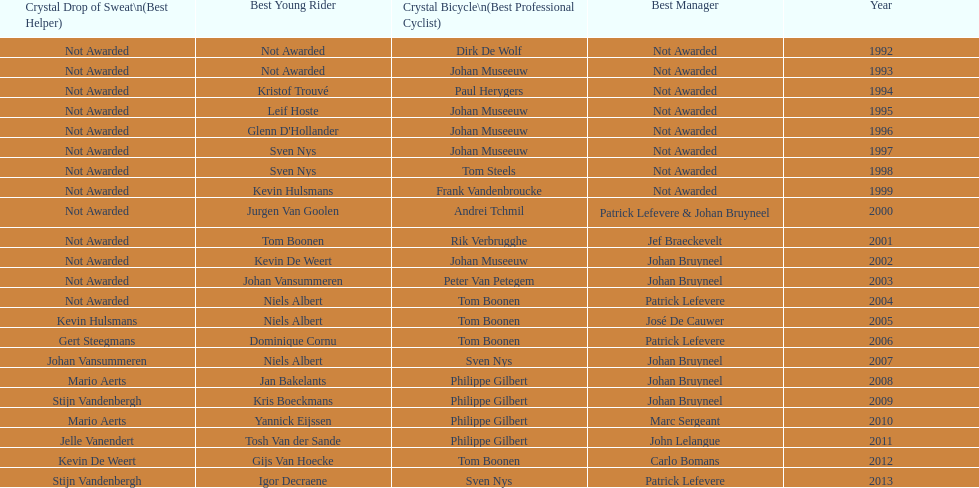Would you mind parsing the complete table? {'header': ['Crystal Drop of Sweat\\n(Best Helper)', 'Best Young Rider', 'Crystal Bicycle\\n(Best Professional Cyclist)', 'Best Manager', 'Year'], 'rows': [['Not Awarded', 'Not Awarded', 'Dirk De Wolf', 'Not Awarded', '1992'], ['Not Awarded', 'Not Awarded', 'Johan Museeuw', 'Not Awarded', '1993'], ['Not Awarded', 'Kristof Trouvé', 'Paul Herygers', 'Not Awarded', '1994'], ['Not Awarded', 'Leif Hoste', 'Johan Museeuw', 'Not Awarded', '1995'], ['Not Awarded', "Glenn D'Hollander", 'Johan Museeuw', 'Not Awarded', '1996'], ['Not Awarded', 'Sven Nys', 'Johan Museeuw', 'Not Awarded', '1997'], ['Not Awarded', 'Sven Nys', 'Tom Steels', 'Not Awarded', '1998'], ['Not Awarded', 'Kevin Hulsmans', 'Frank Vandenbroucke', 'Not Awarded', '1999'], ['Not Awarded', 'Jurgen Van Goolen', 'Andrei Tchmil', 'Patrick Lefevere & Johan Bruyneel', '2000'], ['Not Awarded', 'Tom Boonen', 'Rik Verbrugghe', 'Jef Braeckevelt', '2001'], ['Not Awarded', 'Kevin De Weert', 'Johan Museeuw', 'Johan Bruyneel', '2002'], ['Not Awarded', 'Johan Vansummeren', 'Peter Van Petegem', 'Johan Bruyneel', '2003'], ['Not Awarded', 'Niels Albert', 'Tom Boonen', 'Patrick Lefevere', '2004'], ['Kevin Hulsmans', 'Niels Albert', 'Tom Boonen', 'José De Cauwer', '2005'], ['Gert Steegmans', 'Dominique Cornu', 'Tom Boonen', 'Patrick Lefevere', '2006'], ['Johan Vansummeren', 'Niels Albert', 'Sven Nys', 'Johan Bruyneel', '2007'], ['Mario Aerts', 'Jan Bakelants', 'Philippe Gilbert', 'Johan Bruyneel', '2008'], ['Stijn Vandenbergh', 'Kris Boeckmans', 'Philippe Gilbert', 'Johan Bruyneel', '2009'], ['Mario Aerts', 'Yannick Eijssen', 'Philippe Gilbert', 'Marc Sergeant', '2010'], ['Jelle Vanendert', 'Tosh Van der Sande', 'Philippe Gilbert', 'John Lelangue', '2011'], ['Kevin De Weert', 'Gijs Van Hoecke', 'Tom Boonen', 'Carlo Bomans', '2012'], ['Stijn Vandenbergh', 'Igor Decraene', 'Sven Nys', 'Patrick Lefevere', '2013']]} Who has won the most best young rider awards? Niels Albert. 